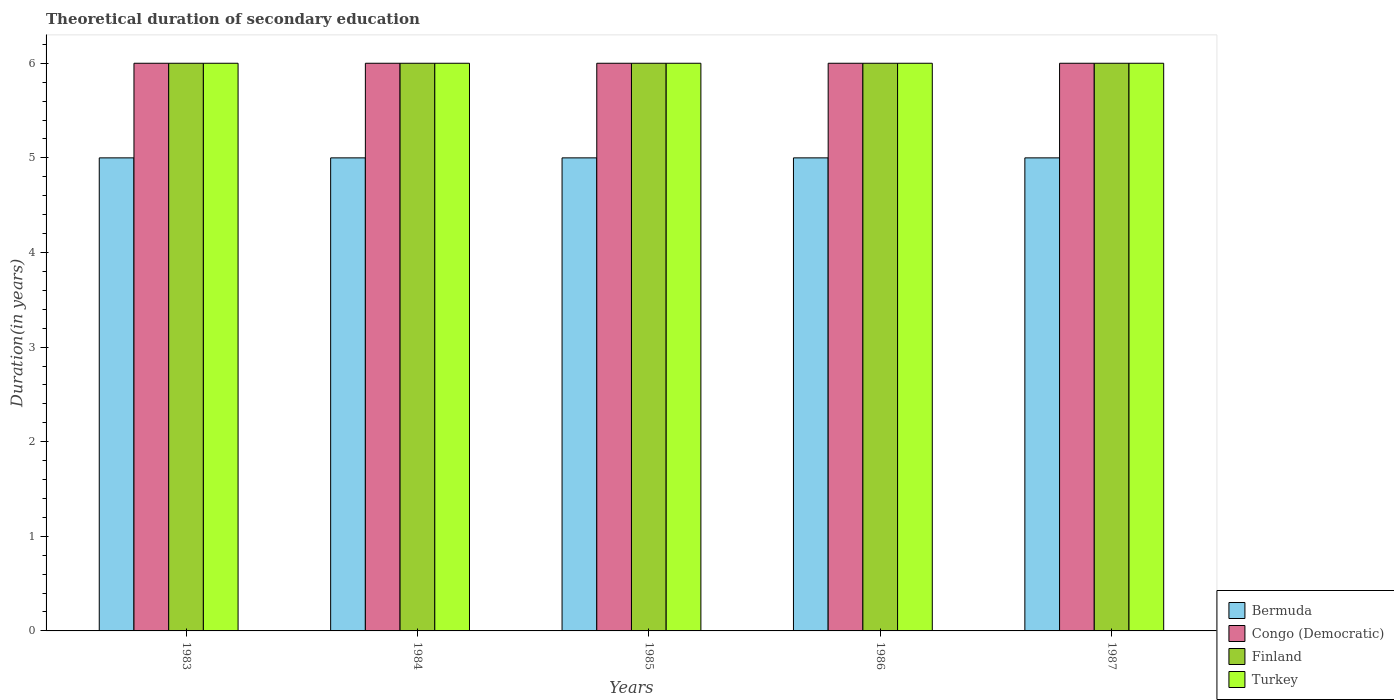How many different coloured bars are there?
Your response must be concise. 4. How many groups of bars are there?
Keep it short and to the point. 5. Are the number of bars on each tick of the X-axis equal?
Ensure brevity in your answer.  Yes. How many bars are there on the 4th tick from the right?
Your answer should be very brief. 4. What is the total theoretical duration of secondary education in Turkey in 1984?
Ensure brevity in your answer.  6. Across all years, what is the maximum total theoretical duration of secondary education in Congo (Democratic)?
Provide a succinct answer. 6. Across all years, what is the minimum total theoretical duration of secondary education in Bermuda?
Your answer should be compact. 5. In which year was the total theoretical duration of secondary education in Congo (Democratic) maximum?
Make the answer very short. 1983. In which year was the total theoretical duration of secondary education in Turkey minimum?
Your response must be concise. 1983. What is the total total theoretical duration of secondary education in Finland in the graph?
Offer a terse response. 30. In the year 1984, what is the difference between the total theoretical duration of secondary education in Bermuda and total theoretical duration of secondary education in Turkey?
Ensure brevity in your answer.  -1. In how many years, is the total theoretical duration of secondary education in Congo (Democratic) greater than 3.4 years?
Give a very brief answer. 5. Is the total theoretical duration of secondary education in Congo (Democratic) in 1984 less than that in 1985?
Make the answer very short. No. What is the difference between the highest and the second highest total theoretical duration of secondary education in Finland?
Your answer should be compact. 0. What is the difference between the highest and the lowest total theoretical duration of secondary education in Congo (Democratic)?
Ensure brevity in your answer.  0. In how many years, is the total theoretical duration of secondary education in Congo (Democratic) greater than the average total theoretical duration of secondary education in Congo (Democratic) taken over all years?
Your answer should be very brief. 0. Is the sum of the total theoretical duration of secondary education in Turkey in 1984 and 1987 greater than the maximum total theoretical duration of secondary education in Bermuda across all years?
Ensure brevity in your answer.  Yes. What does the 2nd bar from the left in 1986 represents?
Your answer should be compact. Congo (Democratic). Is it the case that in every year, the sum of the total theoretical duration of secondary education in Turkey and total theoretical duration of secondary education in Finland is greater than the total theoretical duration of secondary education in Congo (Democratic)?
Your response must be concise. Yes. Are all the bars in the graph horizontal?
Ensure brevity in your answer.  No. Does the graph contain grids?
Give a very brief answer. No. Where does the legend appear in the graph?
Your response must be concise. Bottom right. What is the title of the graph?
Offer a very short reply. Theoretical duration of secondary education. Does "Fiji" appear as one of the legend labels in the graph?
Your answer should be compact. No. What is the label or title of the Y-axis?
Ensure brevity in your answer.  Duration(in years). What is the Duration(in years) in Congo (Democratic) in 1983?
Provide a succinct answer. 6. What is the Duration(in years) of Bermuda in 1984?
Offer a very short reply. 5. What is the Duration(in years) of Congo (Democratic) in 1984?
Make the answer very short. 6. What is the Duration(in years) of Finland in 1984?
Make the answer very short. 6. What is the Duration(in years) of Turkey in 1984?
Your answer should be very brief. 6. What is the Duration(in years) in Bermuda in 1985?
Offer a very short reply. 5. What is the Duration(in years) in Turkey in 1985?
Ensure brevity in your answer.  6. What is the Duration(in years) of Bermuda in 1986?
Make the answer very short. 5. What is the Duration(in years) of Bermuda in 1987?
Keep it short and to the point. 5. What is the Duration(in years) of Finland in 1987?
Your answer should be very brief. 6. What is the Duration(in years) in Turkey in 1987?
Offer a very short reply. 6. Across all years, what is the maximum Duration(in years) in Bermuda?
Offer a terse response. 5. Across all years, what is the maximum Duration(in years) of Finland?
Make the answer very short. 6. Across all years, what is the minimum Duration(in years) in Bermuda?
Keep it short and to the point. 5. Across all years, what is the minimum Duration(in years) in Congo (Democratic)?
Make the answer very short. 6. Across all years, what is the minimum Duration(in years) in Finland?
Give a very brief answer. 6. Across all years, what is the minimum Duration(in years) in Turkey?
Your response must be concise. 6. What is the total Duration(in years) in Bermuda in the graph?
Give a very brief answer. 25. What is the total Duration(in years) of Congo (Democratic) in the graph?
Make the answer very short. 30. What is the total Duration(in years) of Turkey in the graph?
Your answer should be compact. 30. What is the difference between the Duration(in years) of Congo (Democratic) in 1983 and that in 1984?
Provide a short and direct response. 0. What is the difference between the Duration(in years) in Finland in 1983 and that in 1984?
Give a very brief answer. 0. What is the difference between the Duration(in years) of Turkey in 1983 and that in 1985?
Your response must be concise. 0. What is the difference between the Duration(in years) in Bermuda in 1983 and that in 1986?
Make the answer very short. 0. What is the difference between the Duration(in years) of Turkey in 1983 and that in 1986?
Give a very brief answer. 0. What is the difference between the Duration(in years) of Congo (Democratic) in 1984 and that in 1985?
Ensure brevity in your answer.  0. What is the difference between the Duration(in years) in Turkey in 1984 and that in 1985?
Your response must be concise. 0. What is the difference between the Duration(in years) in Congo (Democratic) in 1984 and that in 1986?
Ensure brevity in your answer.  0. What is the difference between the Duration(in years) in Finland in 1984 and that in 1986?
Offer a terse response. 0. What is the difference between the Duration(in years) in Turkey in 1984 and that in 1986?
Keep it short and to the point. 0. What is the difference between the Duration(in years) of Bermuda in 1984 and that in 1987?
Keep it short and to the point. 0. What is the difference between the Duration(in years) of Congo (Democratic) in 1984 and that in 1987?
Make the answer very short. 0. What is the difference between the Duration(in years) of Finland in 1984 and that in 1987?
Keep it short and to the point. 0. What is the difference between the Duration(in years) in Turkey in 1984 and that in 1987?
Give a very brief answer. 0. What is the difference between the Duration(in years) in Bermuda in 1985 and that in 1986?
Give a very brief answer. 0. What is the difference between the Duration(in years) in Congo (Democratic) in 1985 and that in 1986?
Provide a short and direct response. 0. What is the difference between the Duration(in years) of Finland in 1985 and that in 1986?
Your answer should be very brief. 0. What is the difference between the Duration(in years) of Turkey in 1985 and that in 1986?
Your answer should be compact. 0. What is the difference between the Duration(in years) in Congo (Democratic) in 1985 and that in 1987?
Provide a succinct answer. 0. What is the difference between the Duration(in years) in Congo (Democratic) in 1986 and that in 1987?
Give a very brief answer. 0. What is the difference between the Duration(in years) in Finland in 1986 and that in 1987?
Keep it short and to the point. 0. What is the difference between the Duration(in years) in Bermuda in 1983 and the Duration(in years) in Congo (Democratic) in 1984?
Keep it short and to the point. -1. What is the difference between the Duration(in years) in Bermuda in 1983 and the Duration(in years) in Finland in 1984?
Keep it short and to the point. -1. What is the difference between the Duration(in years) in Bermuda in 1983 and the Duration(in years) in Turkey in 1984?
Give a very brief answer. -1. What is the difference between the Duration(in years) of Congo (Democratic) in 1983 and the Duration(in years) of Finland in 1984?
Your answer should be compact. 0. What is the difference between the Duration(in years) of Finland in 1983 and the Duration(in years) of Turkey in 1984?
Provide a succinct answer. 0. What is the difference between the Duration(in years) in Bermuda in 1983 and the Duration(in years) in Finland in 1985?
Provide a succinct answer. -1. What is the difference between the Duration(in years) in Congo (Democratic) in 1983 and the Duration(in years) in Finland in 1985?
Provide a short and direct response. 0. What is the difference between the Duration(in years) in Finland in 1983 and the Duration(in years) in Turkey in 1985?
Give a very brief answer. 0. What is the difference between the Duration(in years) in Bermuda in 1983 and the Duration(in years) in Finland in 1986?
Your answer should be compact. -1. What is the difference between the Duration(in years) in Bermuda in 1983 and the Duration(in years) in Turkey in 1986?
Your answer should be compact. -1. What is the difference between the Duration(in years) of Congo (Democratic) in 1983 and the Duration(in years) of Finland in 1986?
Provide a succinct answer. 0. What is the difference between the Duration(in years) of Congo (Democratic) in 1983 and the Duration(in years) of Turkey in 1987?
Provide a succinct answer. 0. What is the difference between the Duration(in years) in Bermuda in 1984 and the Duration(in years) in Finland in 1985?
Your answer should be compact. -1. What is the difference between the Duration(in years) in Congo (Democratic) in 1984 and the Duration(in years) in Turkey in 1985?
Keep it short and to the point. 0. What is the difference between the Duration(in years) in Finland in 1984 and the Duration(in years) in Turkey in 1985?
Keep it short and to the point. 0. What is the difference between the Duration(in years) in Bermuda in 1984 and the Duration(in years) in Finland in 1986?
Your answer should be very brief. -1. What is the difference between the Duration(in years) in Congo (Democratic) in 1984 and the Duration(in years) in Finland in 1986?
Make the answer very short. 0. What is the difference between the Duration(in years) of Congo (Democratic) in 1984 and the Duration(in years) of Turkey in 1986?
Offer a terse response. 0. What is the difference between the Duration(in years) of Bermuda in 1984 and the Duration(in years) of Turkey in 1987?
Make the answer very short. -1. What is the difference between the Duration(in years) in Congo (Democratic) in 1984 and the Duration(in years) in Turkey in 1987?
Your answer should be very brief. 0. What is the difference between the Duration(in years) of Finland in 1984 and the Duration(in years) of Turkey in 1987?
Your answer should be compact. 0. What is the difference between the Duration(in years) in Bermuda in 1985 and the Duration(in years) in Congo (Democratic) in 1986?
Offer a terse response. -1. What is the difference between the Duration(in years) of Congo (Democratic) in 1985 and the Duration(in years) of Finland in 1986?
Keep it short and to the point. 0. What is the difference between the Duration(in years) of Congo (Democratic) in 1985 and the Duration(in years) of Turkey in 1986?
Your answer should be very brief. 0. What is the difference between the Duration(in years) in Bermuda in 1985 and the Duration(in years) in Finland in 1987?
Provide a short and direct response. -1. What is the difference between the Duration(in years) of Congo (Democratic) in 1986 and the Duration(in years) of Finland in 1987?
Ensure brevity in your answer.  0. What is the difference between the Duration(in years) in Congo (Democratic) in 1986 and the Duration(in years) in Turkey in 1987?
Your response must be concise. 0. In the year 1983, what is the difference between the Duration(in years) in Bermuda and Duration(in years) in Congo (Democratic)?
Ensure brevity in your answer.  -1. In the year 1983, what is the difference between the Duration(in years) in Bermuda and Duration(in years) in Turkey?
Your answer should be very brief. -1. In the year 1983, what is the difference between the Duration(in years) of Finland and Duration(in years) of Turkey?
Ensure brevity in your answer.  0. In the year 1984, what is the difference between the Duration(in years) in Bermuda and Duration(in years) in Congo (Democratic)?
Provide a short and direct response. -1. In the year 1984, what is the difference between the Duration(in years) of Congo (Democratic) and Duration(in years) of Finland?
Make the answer very short. 0. In the year 1984, what is the difference between the Duration(in years) of Finland and Duration(in years) of Turkey?
Your answer should be very brief. 0. In the year 1985, what is the difference between the Duration(in years) in Bermuda and Duration(in years) in Congo (Democratic)?
Offer a very short reply. -1. In the year 1985, what is the difference between the Duration(in years) in Bermuda and Duration(in years) in Finland?
Your response must be concise. -1. In the year 1985, what is the difference between the Duration(in years) of Bermuda and Duration(in years) of Turkey?
Offer a terse response. -1. In the year 1986, what is the difference between the Duration(in years) of Bermuda and Duration(in years) of Congo (Democratic)?
Your answer should be compact. -1. In the year 1986, what is the difference between the Duration(in years) of Congo (Democratic) and Duration(in years) of Finland?
Keep it short and to the point. 0. In the year 1986, what is the difference between the Duration(in years) in Congo (Democratic) and Duration(in years) in Turkey?
Provide a short and direct response. 0. In the year 1987, what is the difference between the Duration(in years) of Bermuda and Duration(in years) of Turkey?
Offer a very short reply. -1. In the year 1987, what is the difference between the Duration(in years) in Congo (Democratic) and Duration(in years) in Finland?
Provide a short and direct response. 0. In the year 1987, what is the difference between the Duration(in years) of Finland and Duration(in years) of Turkey?
Offer a terse response. 0. What is the ratio of the Duration(in years) in Congo (Democratic) in 1983 to that in 1984?
Your answer should be compact. 1. What is the ratio of the Duration(in years) of Turkey in 1983 to that in 1984?
Keep it short and to the point. 1. What is the ratio of the Duration(in years) of Congo (Democratic) in 1983 to that in 1985?
Ensure brevity in your answer.  1. What is the ratio of the Duration(in years) of Turkey in 1983 to that in 1985?
Your response must be concise. 1. What is the ratio of the Duration(in years) in Congo (Democratic) in 1983 to that in 1986?
Your answer should be compact. 1. What is the ratio of the Duration(in years) of Bermuda in 1983 to that in 1987?
Your answer should be very brief. 1. What is the ratio of the Duration(in years) of Bermuda in 1984 to that in 1985?
Offer a very short reply. 1. What is the ratio of the Duration(in years) of Finland in 1984 to that in 1985?
Keep it short and to the point. 1. What is the ratio of the Duration(in years) of Turkey in 1984 to that in 1985?
Your answer should be very brief. 1. What is the ratio of the Duration(in years) in Congo (Democratic) in 1984 to that in 1986?
Make the answer very short. 1. What is the ratio of the Duration(in years) in Bermuda in 1984 to that in 1987?
Give a very brief answer. 1. What is the ratio of the Duration(in years) in Congo (Democratic) in 1984 to that in 1987?
Make the answer very short. 1. What is the ratio of the Duration(in years) of Turkey in 1984 to that in 1987?
Keep it short and to the point. 1. What is the ratio of the Duration(in years) of Bermuda in 1985 to that in 1986?
Your answer should be compact. 1. What is the ratio of the Duration(in years) in Congo (Democratic) in 1985 to that in 1986?
Your response must be concise. 1. What is the ratio of the Duration(in years) in Finland in 1985 to that in 1986?
Your response must be concise. 1. What is the ratio of the Duration(in years) in Turkey in 1985 to that in 1986?
Keep it short and to the point. 1. What is the ratio of the Duration(in years) in Congo (Democratic) in 1985 to that in 1987?
Give a very brief answer. 1. What is the ratio of the Duration(in years) in Finland in 1985 to that in 1987?
Provide a short and direct response. 1. What is the ratio of the Duration(in years) in Bermuda in 1986 to that in 1987?
Give a very brief answer. 1. What is the ratio of the Duration(in years) of Turkey in 1986 to that in 1987?
Keep it short and to the point. 1. What is the difference between the highest and the second highest Duration(in years) in Bermuda?
Your answer should be compact. 0. What is the difference between the highest and the second highest Duration(in years) of Congo (Democratic)?
Keep it short and to the point. 0. 